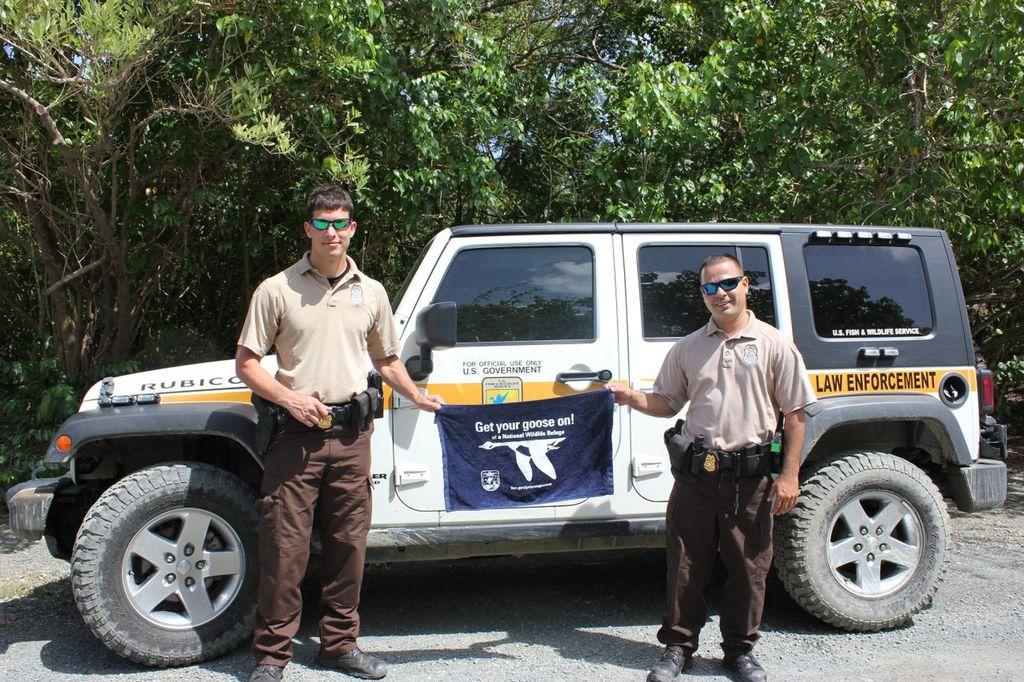How many people are in the image? There are two men standing in the image. What are the men holding in the image? The men are holding a banner. What else can be seen in the image besides the men and the banner? There is a vehicle visible in the image. What can be seen in the background of the image? Trees are present in the background of the image. What type of liquid is being poured from the rings in the image? There are no rings or liquid present in the image. 